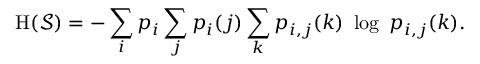<formula> <loc_0><loc_0><loc_500><loc_500>H ( { \mathcal { S } } ) = - \sum _ { i } p _ { i } \sum _ { j } p _ { i } ( j ) \sum _ { k } p _ { i , j } ( k ) \ \log \ p _ { i , j } ( k ) .</formula> 